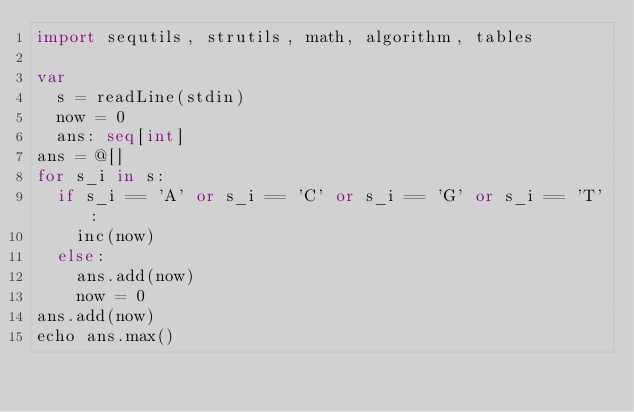Convert code to text. <code><loc_0><loc_0><loc_500><loc_500><_Nim_>import sequtils, strutils, math, algorithm, tables

var
  s = readLine(stdin)
  now = 0
  ans: seq[int]
ans = @[]
for s_i in s:
  if s_i == 'A' or s_i == 'C' or s_i == 'G' or s_i == 'T':
    inc(now)
  else:
    ans.add(now)
    now = 0
ans.add(now)
echo ans.max()</code> 